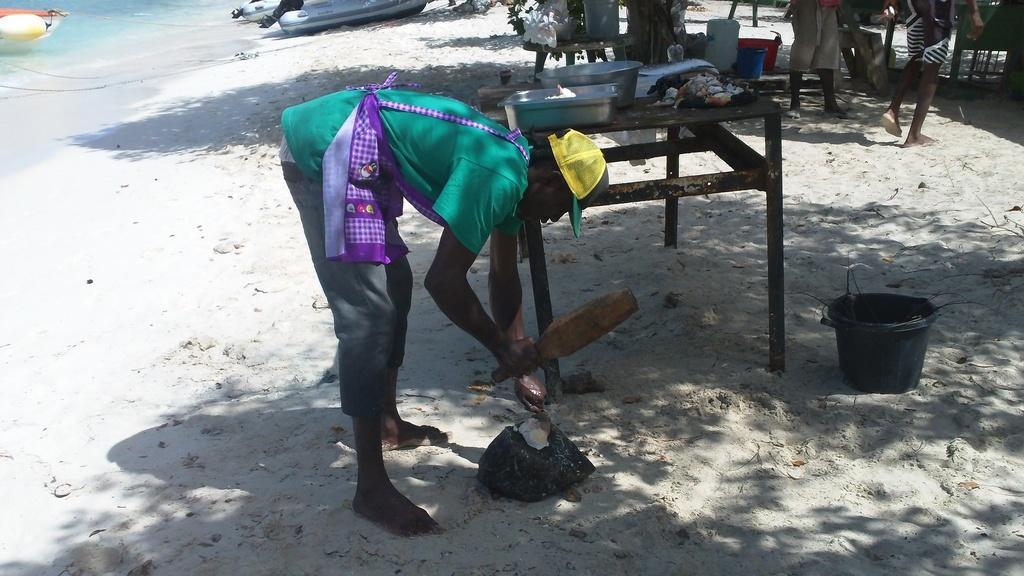Could you give a brief overview of what you see in this image? This is a beach. At the bottom, I can see the sand. In the middle of the image there is a man bending and holding a bat and a bag in the hands. Beside him there is a table on which few bowls and some other objects are placed. Beside the table there is a tub. At the top of the image there are few objects and two persons are standing. In the top left-hand corner, I can see the water and there are boats. 